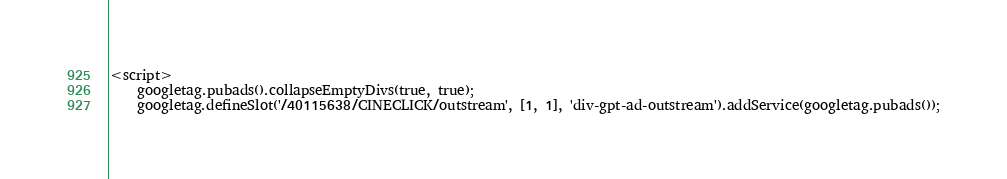<code> <loc_0><loc_0><loc_500><loc_500><_HTML_>
<script>
    googletag.pubads().collapseEmptyDivs(true, true);
    googletag.defineSlot('/40115638/CINECLICK/outstream', [1, 1], 'div-gpt-ad-outstream').addService(googletag.pubads());</code> 